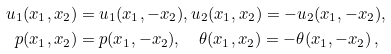<formula> <loc_0><loc_0><loc_500><loc_500>u _ { 1 } ( x _ { 1 } , x _ { 2 } ) & = u _ { 1 } ( x _ { 1 } , - x _ { 2 } ) , u _ { 2 } ( x _ { 1 } , x _ { 2 } ) = - u _ { 2 } ( x _ { 1 } , - x _ { 2 } ) , \\ p ( x _ { 1 } , x _ { 2 } ) & = p ( x _ { 1 } , - x _ { 2 } ) , \quad \theta ( x _ { 1 } , x _ { 2 } ) = - \theta ( x _ { 1 } , - x _ { 2 } ) \, ,</formula> 